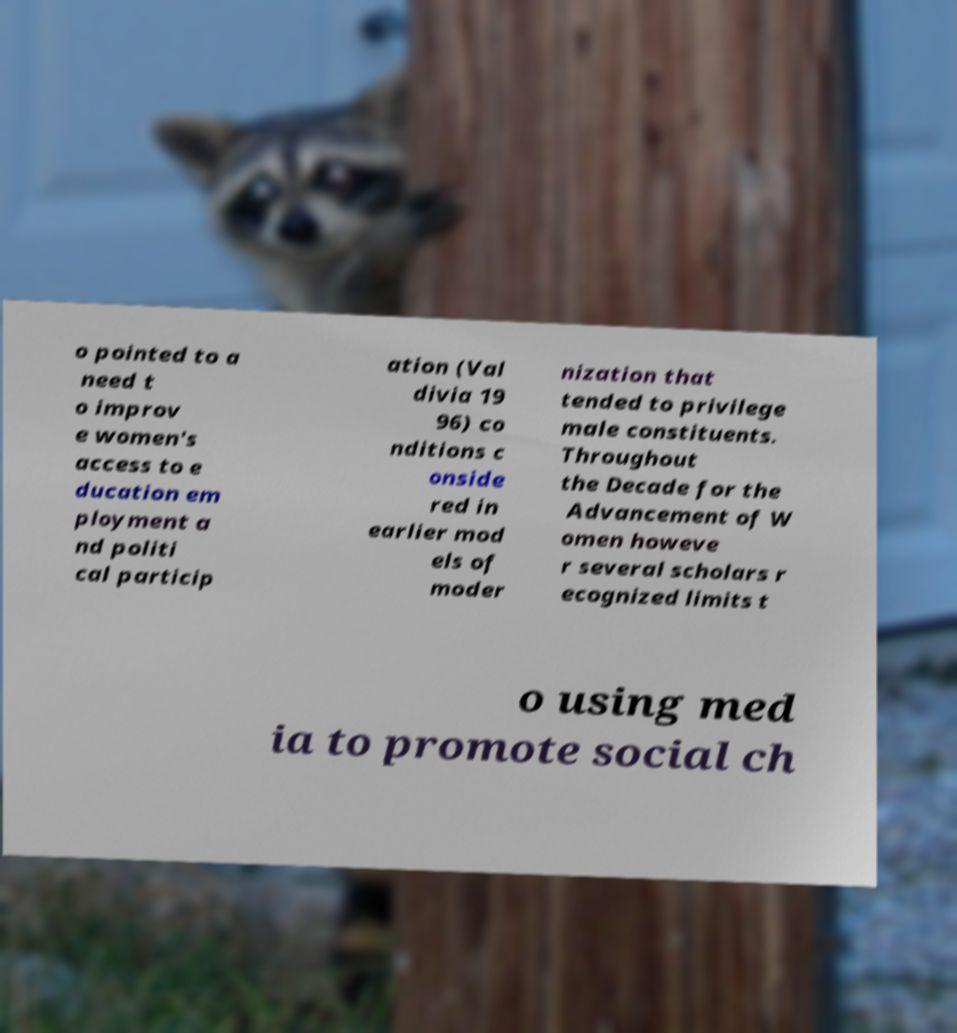What messages or text are displayed in this image? I need them in a readable, typed format. o pointed to a need t o improv e women's access to e ducation em ployment a nd politi cal particip ation (Val divia 19 96) co nditions c onside red in earlier mod els of moder nization that tended to privilege male constituents. Throughout the Decade for the Advancement of W omen howeve r several scholars r ecognized limits t o using med ia to promote social ch 